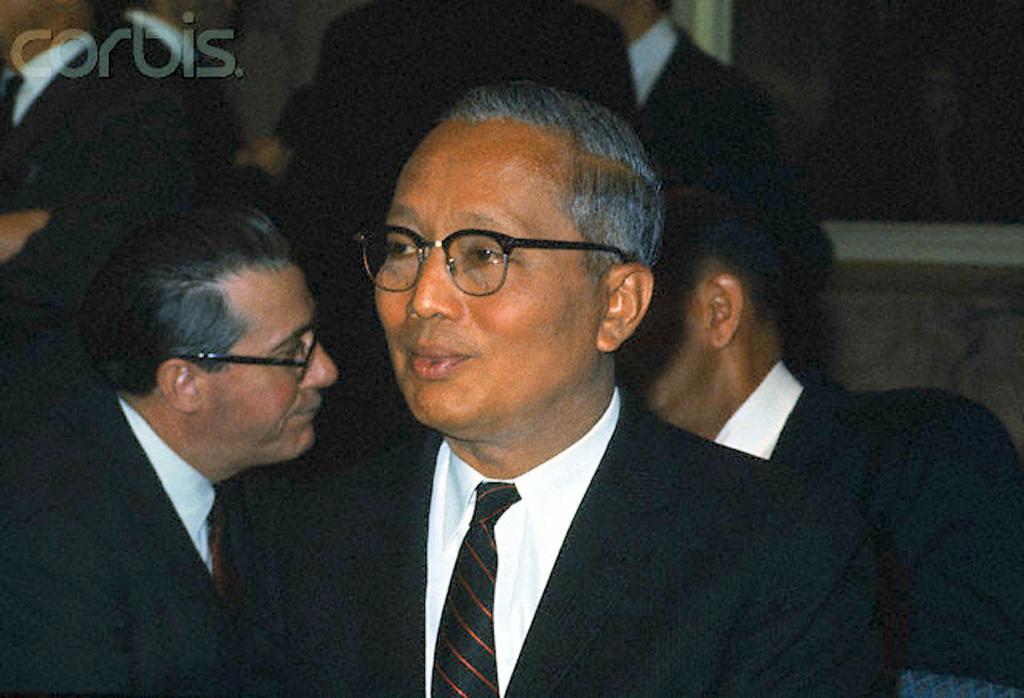In one or two sentences, can you explain what this image depicts? In this image we can see many people. There is a watermark at the top left of the image. There is a window at the right side of the image. 